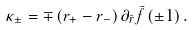<formula> <loc_0><loc_0><loc_500><loc_500>\kappa _ { \pm } = \mp \left ( r _ { + } - r _ { - } \right ) \partial _ { \bar { r } } \bar { f } \left ( \pm 1 \right ) .</formula> 